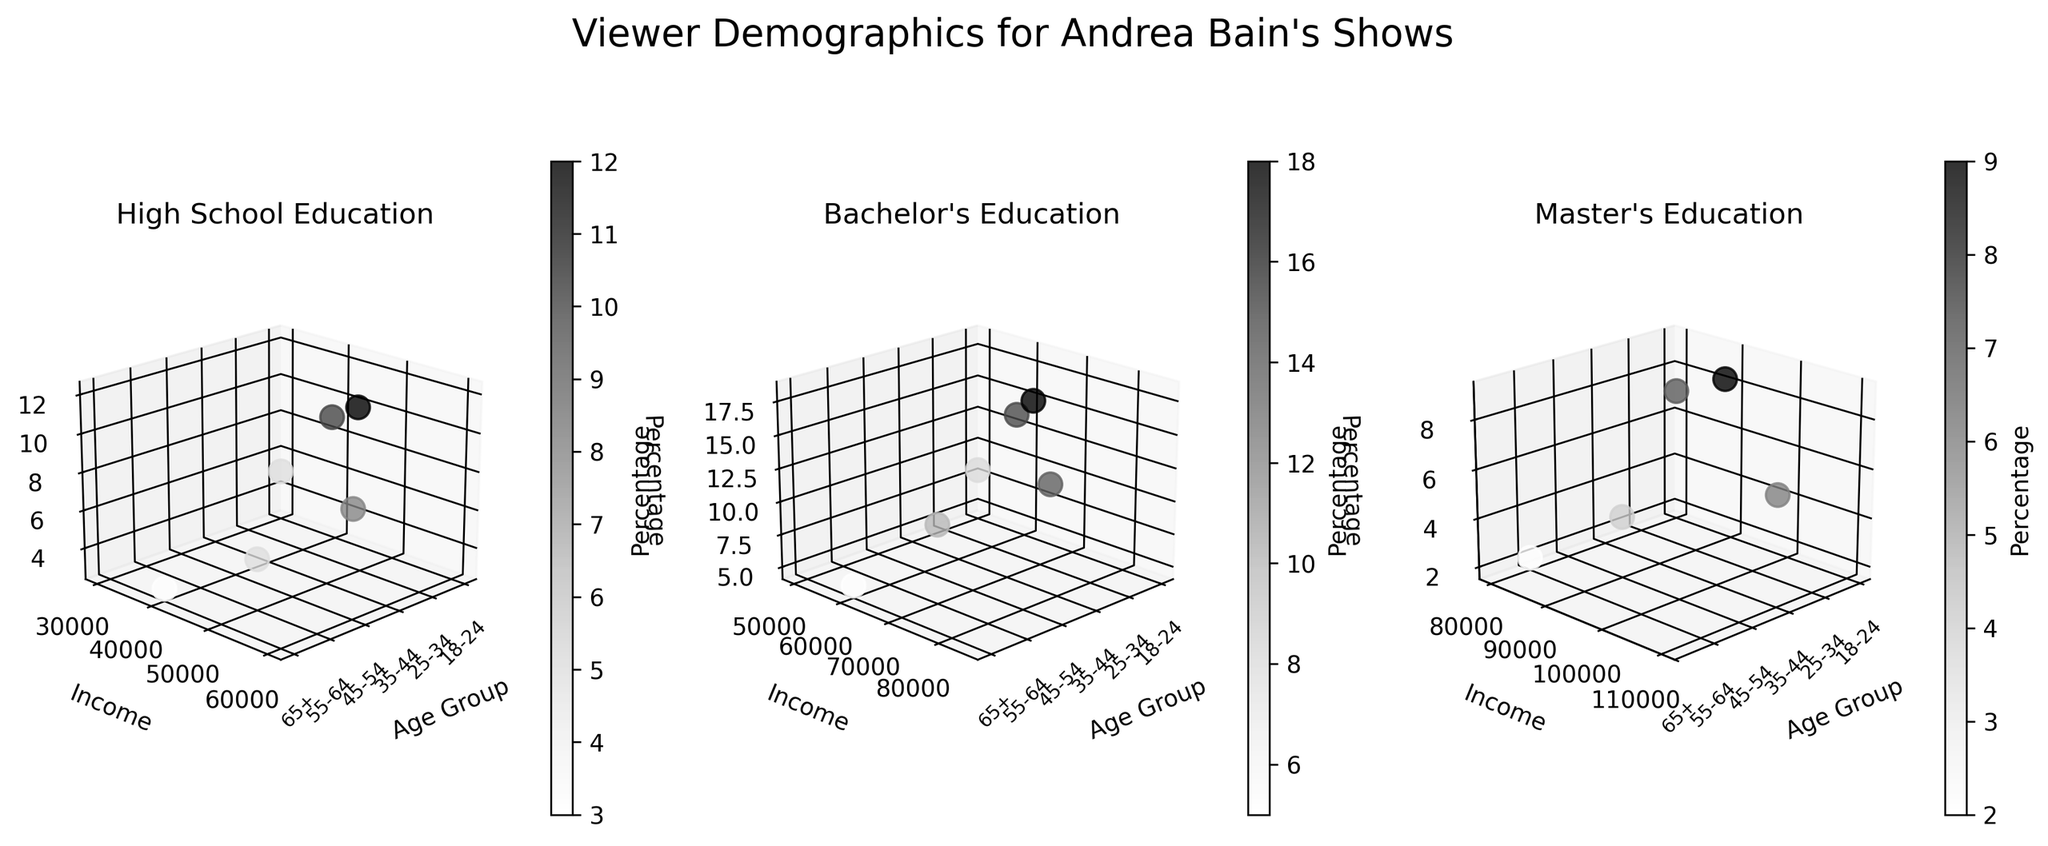How many subplots are there in the figure? The figure contains subplots for each education level. The education levels listed are High School, Bachelor's, and Master's, which means there are three subplots in total.
Answer: 3 What color gradient is used for the scatter points? The scatter points are rendered using a grayscale colormap, as indicated by the color title "Greys" in the code and the resulting visual color gradient from light to dark shades of gray.
Answer: Grayscale Which age group has the highest percentage of viewers with a Bachelor's degree? By looking at the Bachelor's subplot, we observe the Z-axis values. The age group with the highest Z value (Percentage) is 35-44 years old.
Answer: 35-44 years old What is the average income for viewers in the 25-34 age group with a Bachelor's degree? In the Bachelor's subplot, the two income values for the 25-34 age group are $65,000 and $80,000. The average income is (65000 + 80000) / 2 = $72,500.
Answer: $72,500 Compare the percentage of viewers in the age groups 35-44 and 45-54 with a High School education. Which group has a higher percentage? In the High School subplot, the Z-axis value for the 35-44 age group is 12, and for the 45-54 age group, it is 8. Thus, the 35-44 age group has a higher percentage.
Answer: 35-44 years old Which education level has the viewer group with the highest percentage? Looking at the highest Z values across all subplots, the Bachelor's subplot shows the highest percentage at 18%, which occurs in the 35-44 age group.
Answer: Bachelor's What is the total percentage of viewers aged 55-64 years across all education levels? Summing up Z values for the 55-64 age group: High School (5) + Bachelor's (10) + Master's (4). Total is 5 + 10 + 4 = 19.
Answer: 19 How does the income range vary between viewers with a High School and Bachelor's degree in the 25-34 age group? In the High School subplot, the income range for the 25-34 age group is $45,000. In the Bachelor's subplot, the income ranges from $65,000 to $80,000. Hence, Bachelor's degree holders have a wider, higher income range.
Answer: Bachelor's degree holders have a wider range 